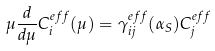<formula> <loc_0><loc_0><loc_500><loc_500>\mu \frac { d } { d \mu } C _ { i } ^ { e f f } ( \mu ) = \gamma _ { i j } ^ { e f f } ( \alpha _ { S } ) C _ { j } ^ { e f f }</formula> 